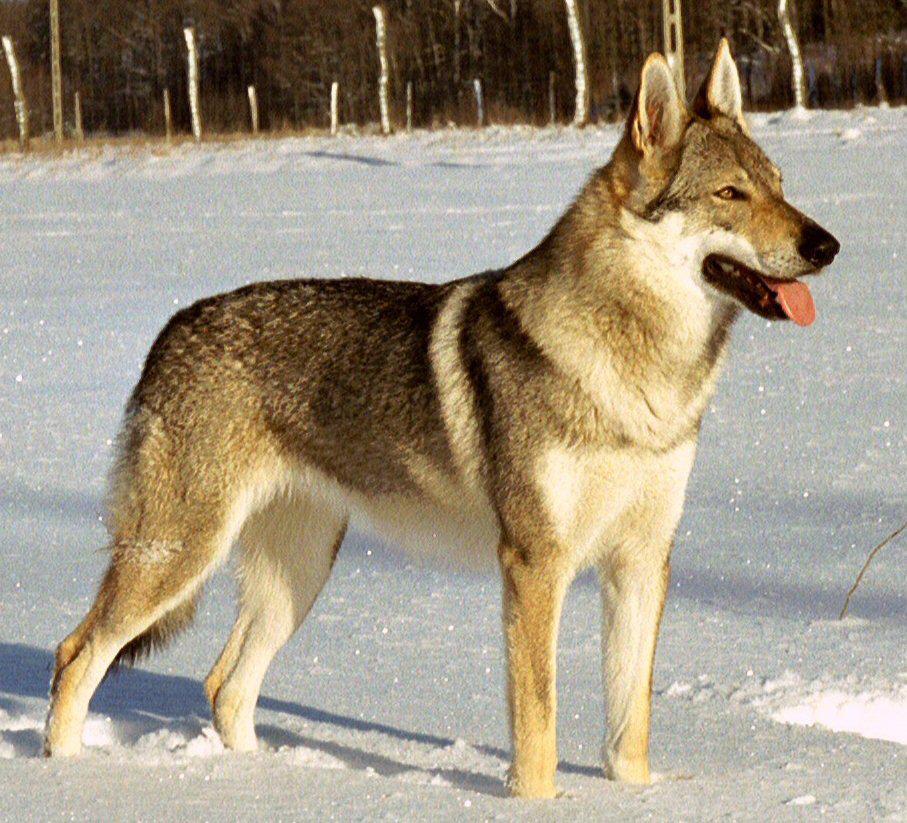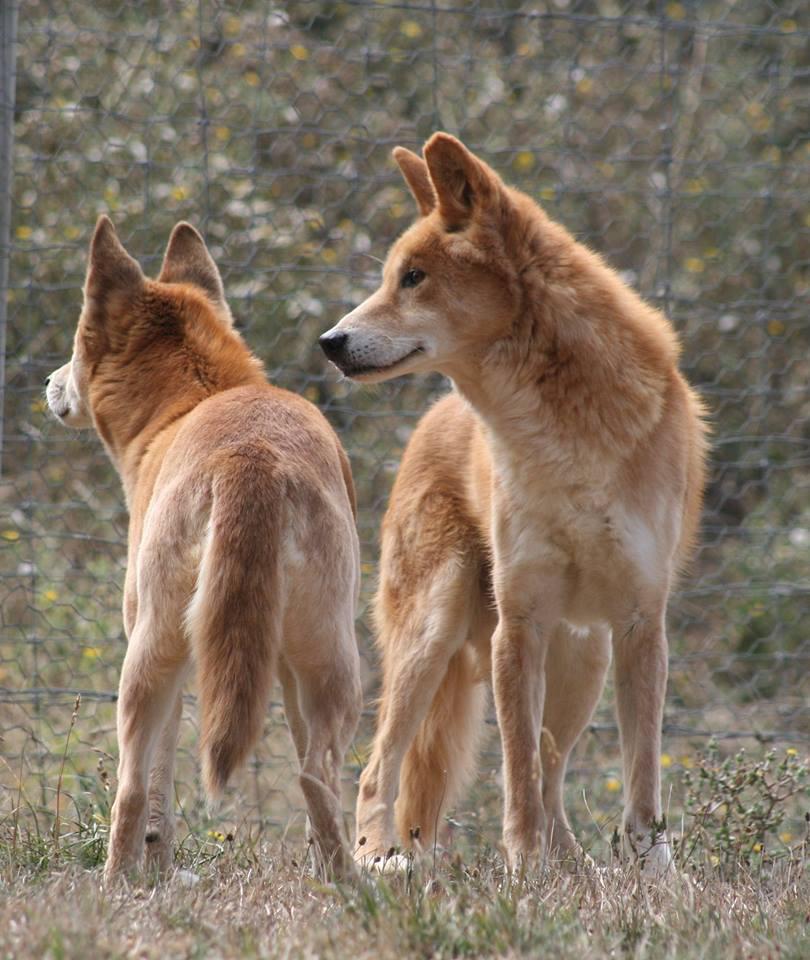The first image is the image on the left, the second image is the image on the right. Analyze the images presented: Is the assertion "There are two animals in the image on the right." valid? Answer yes or no. Yes. 